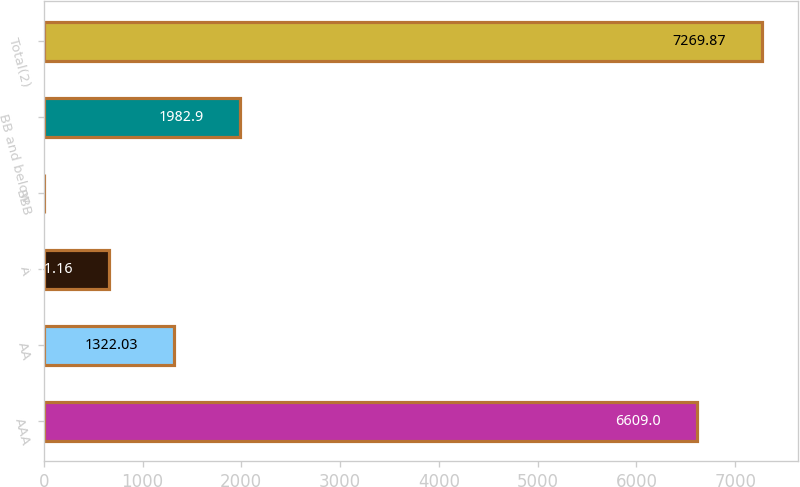Convert chart. <chart><loc_0><loc_0><loc_500><loc_500><bar_chart><fcel>AAA<fcel>AA<fcel>A<fcel>BBB<fcel>BB and below<fcel>Total(2)<nl><fcel>6609<fcel>1322.03<fcel>661.16<fcel>0.29<fcel>1982.9<fcel>7269.87<nl></chart> 